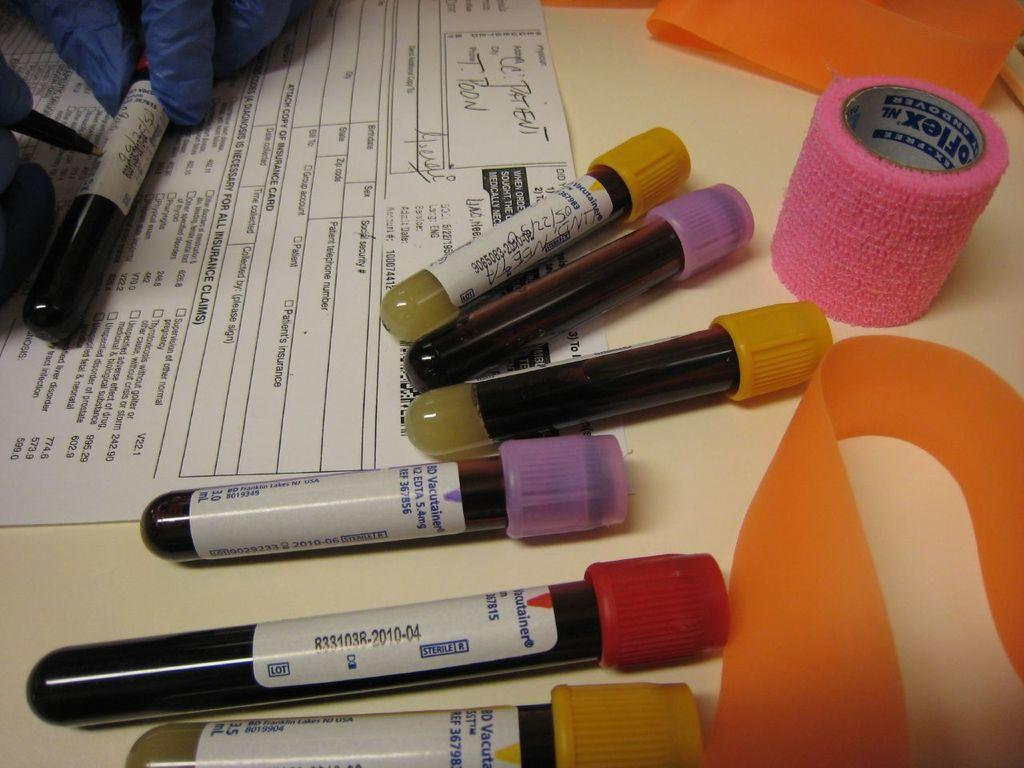What type of objects can be seen in the image? There are test tubes in the image. Where are these objects located? The objects are on a table in the image. What else is present on the table? There is paper on the table in the image. Can you describe the activity being performed in the image? In the left top corner of the image, there are person's fingers and a pencil, suggesting that someone is writing or drawing on the paper. What type of hospital can be seen in the background of the image? There is no hospital present in the image; it only features test tubes, objects on a table, paper, and a person's fingers and a pencil. 